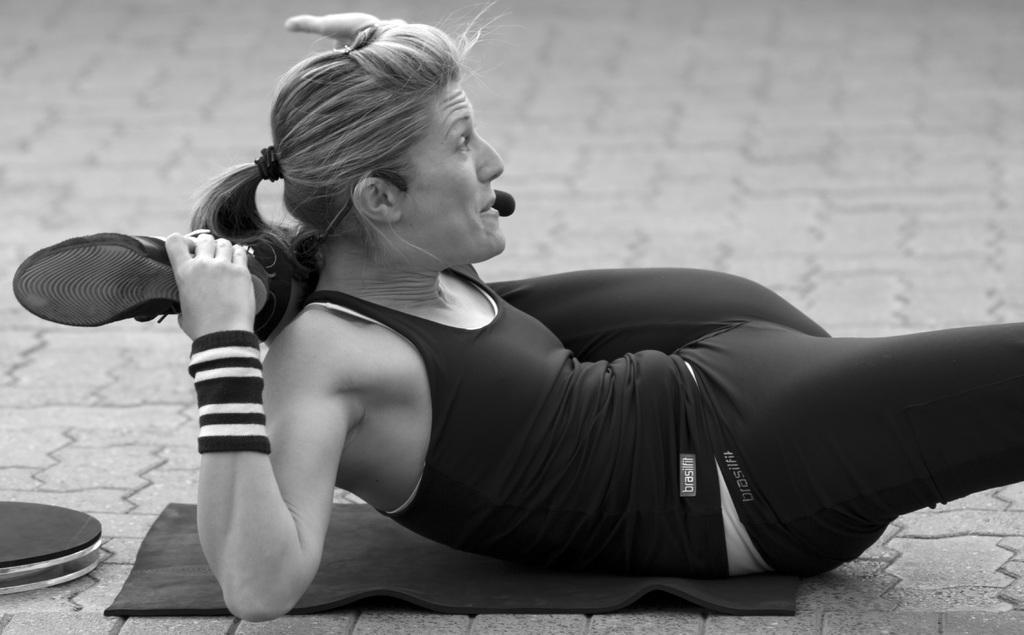Can you describe this image briefly? In this image I can see a woman wearing black dress is laying on the black colored material which is on the ground. To the left side of the image I can see a object which is black in color and in the background I can see the ground. 